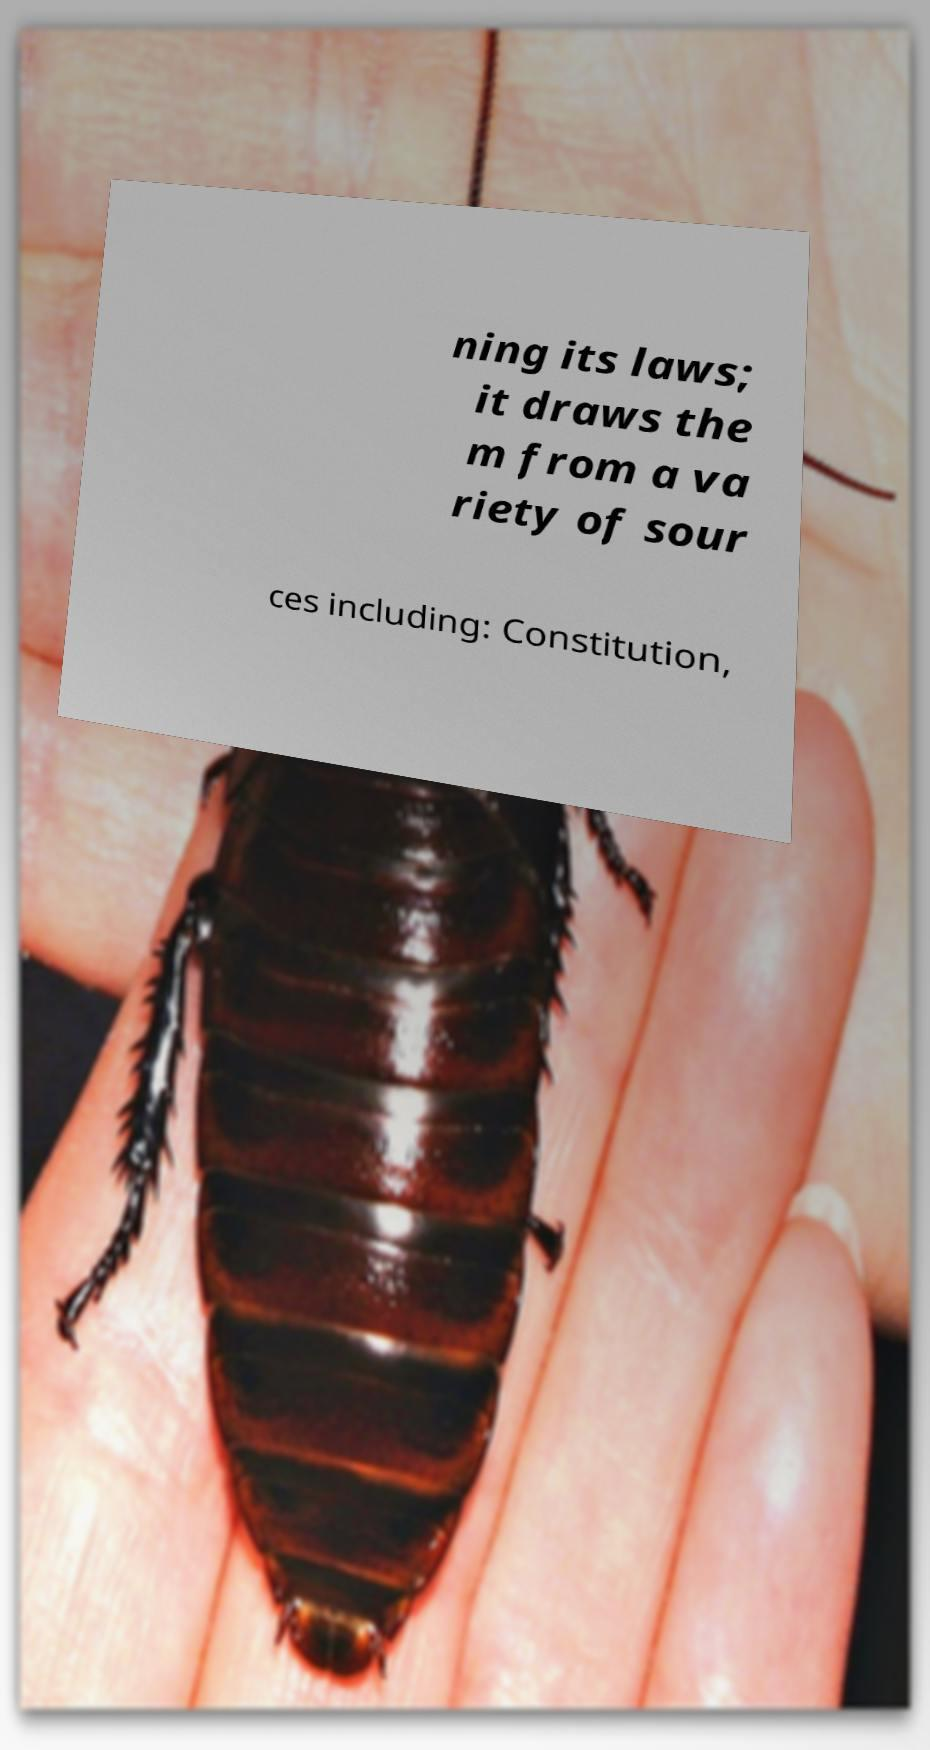I need the written content from this picture converted into text. Can you do that? ning its laws; it draws the m from a va riety of sour ces including: Constitution, 